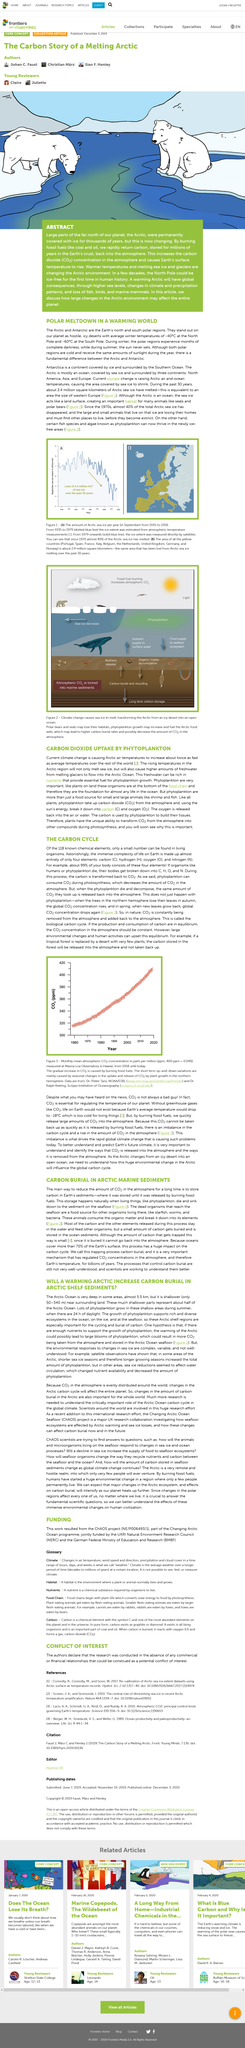Mention a couple of crucial points in this snapshot. The northernmost part of the planet is called the Arctic. The North Pole is projected to be ice-free in just a few decades, according to recent scientific predictions. CO2 stands for carbon dioxide, a common gas composed of one carbon atom and two oxygen atoms that is naturally present in the Earth's atmosphere. The average winter temperature at the South Pole is approximately -60 degrees Celsius. The name of the north polar region is Arctic. 